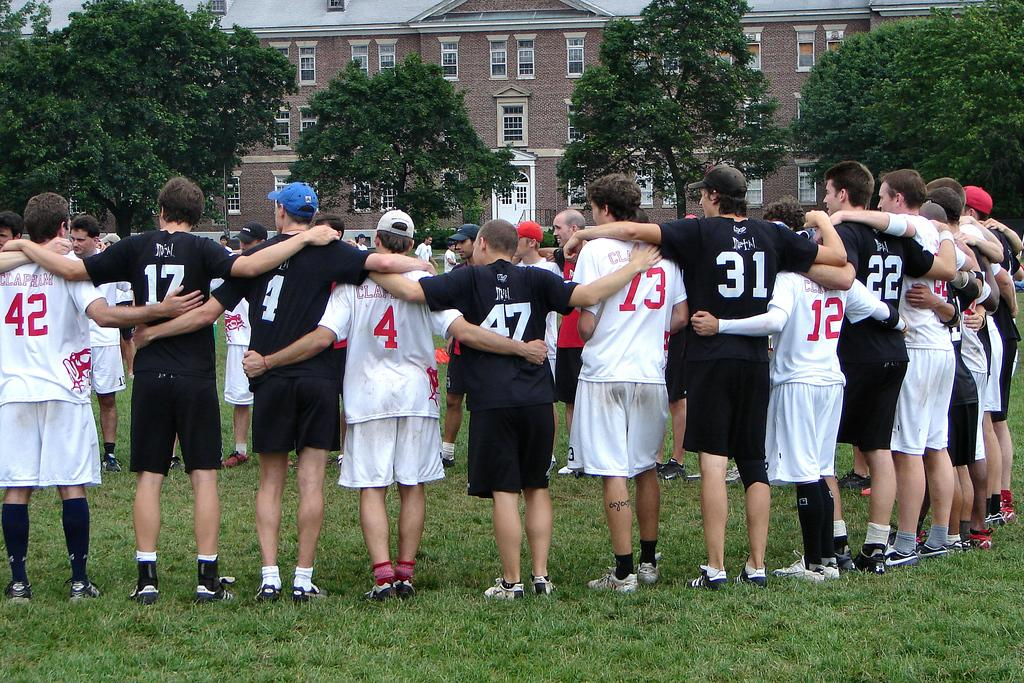What is happening in the image involving a group of people? There is a group of players in the image, and they are holding their hands. What can be seen in the background of the image? There are trees and a brown color brick building visible in the background of the image. Can you tell me how many people are walking in the image? There is no indication of anyone walking in the image; the players are holding their hands. 